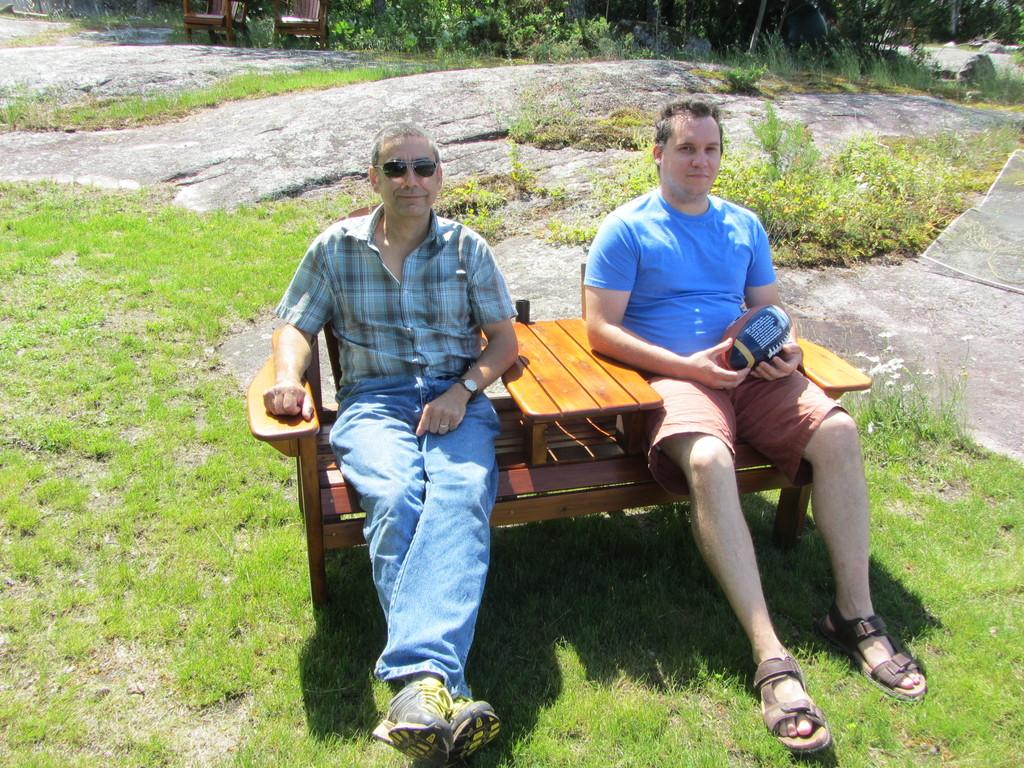How many people are in the foreground of the image? There are two men in the foreground of the image. What are the men doing in the image? The men are sitting on chairs in the image. What type of natural environment is visible in the image? There is grass, plants, and trees visible in the image. How many chairs are in the background of the image? There are two chairs in the background of the image. What type of rhythm can be heard coming from the trees in the image? There is no sound or rhythm present in the image, as it is a still photograph. 